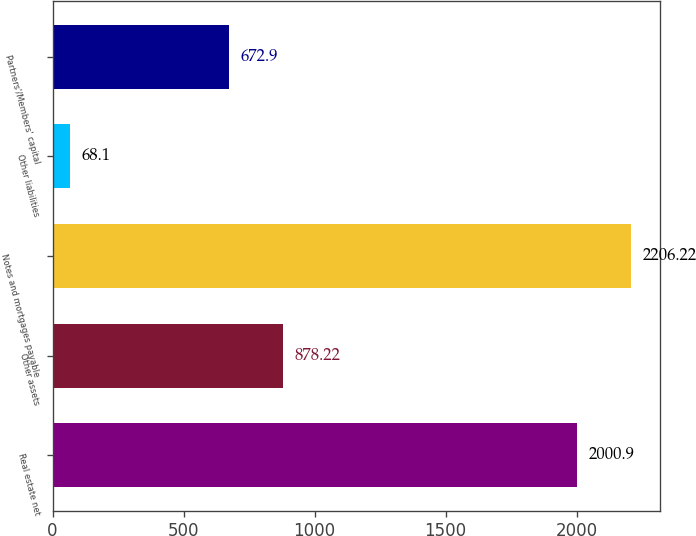Convert chart. <chart><loc_0><loc_0><loc_500><loc_500><bar_chart><fcel>Real estate net<fcel>Other assets<fcel>Notes and mortgages payable<fcel>Other liabilities<fcel>Partners'/Members' capital<nl><fcel>2000.9<fcel>878.22<fcel>2206.22<fcel>68.1<fcel>672.9<nl></chart> 